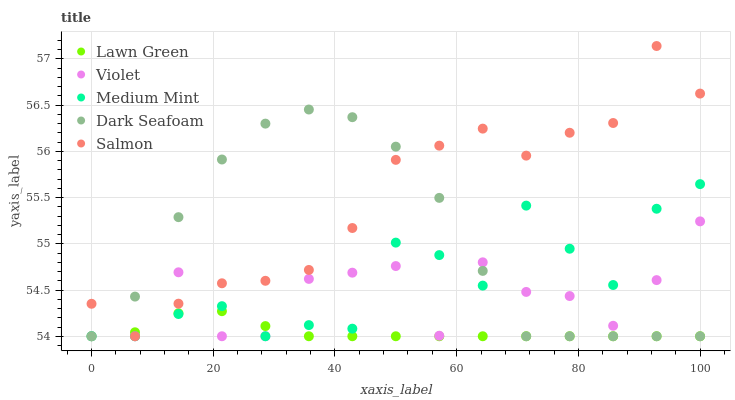Does Lawn Green have the minimum area under the curve?
Answer yes or no. Yes. Does Salmon have the maximum area under the curve?
Answer yes or no. Yes. Does Dark Seafoam have the minimum area under the curve?
Answer yes or no. No. Does Dark Seafoam have the maximum area under the curve?
Answer yes or no. No. Is Lawn Green the smoothest?
Answer yes or no. Yes. Is Violet the roughest?
Answer yes or no. Yes. Is Dark Seafoam the smoothest?
Answer yes or no. No. Is Dark Seafoam the roughest?
Answer yes or no. No. Does Medium Mint have the lowest value?
Answer yes or no. Yes. Does Salmon have the highest value?
Answer yes or no. Yes. Does Dark Seafoam have the highest value?
Answer yes or no. No. Does Salmon intersect Violet?
Answer yes or no. Yes. Is Salmon less than Violet?
Answer yes or no. No. Is Salmon greater than Violet?
Answer yes or no. No. 